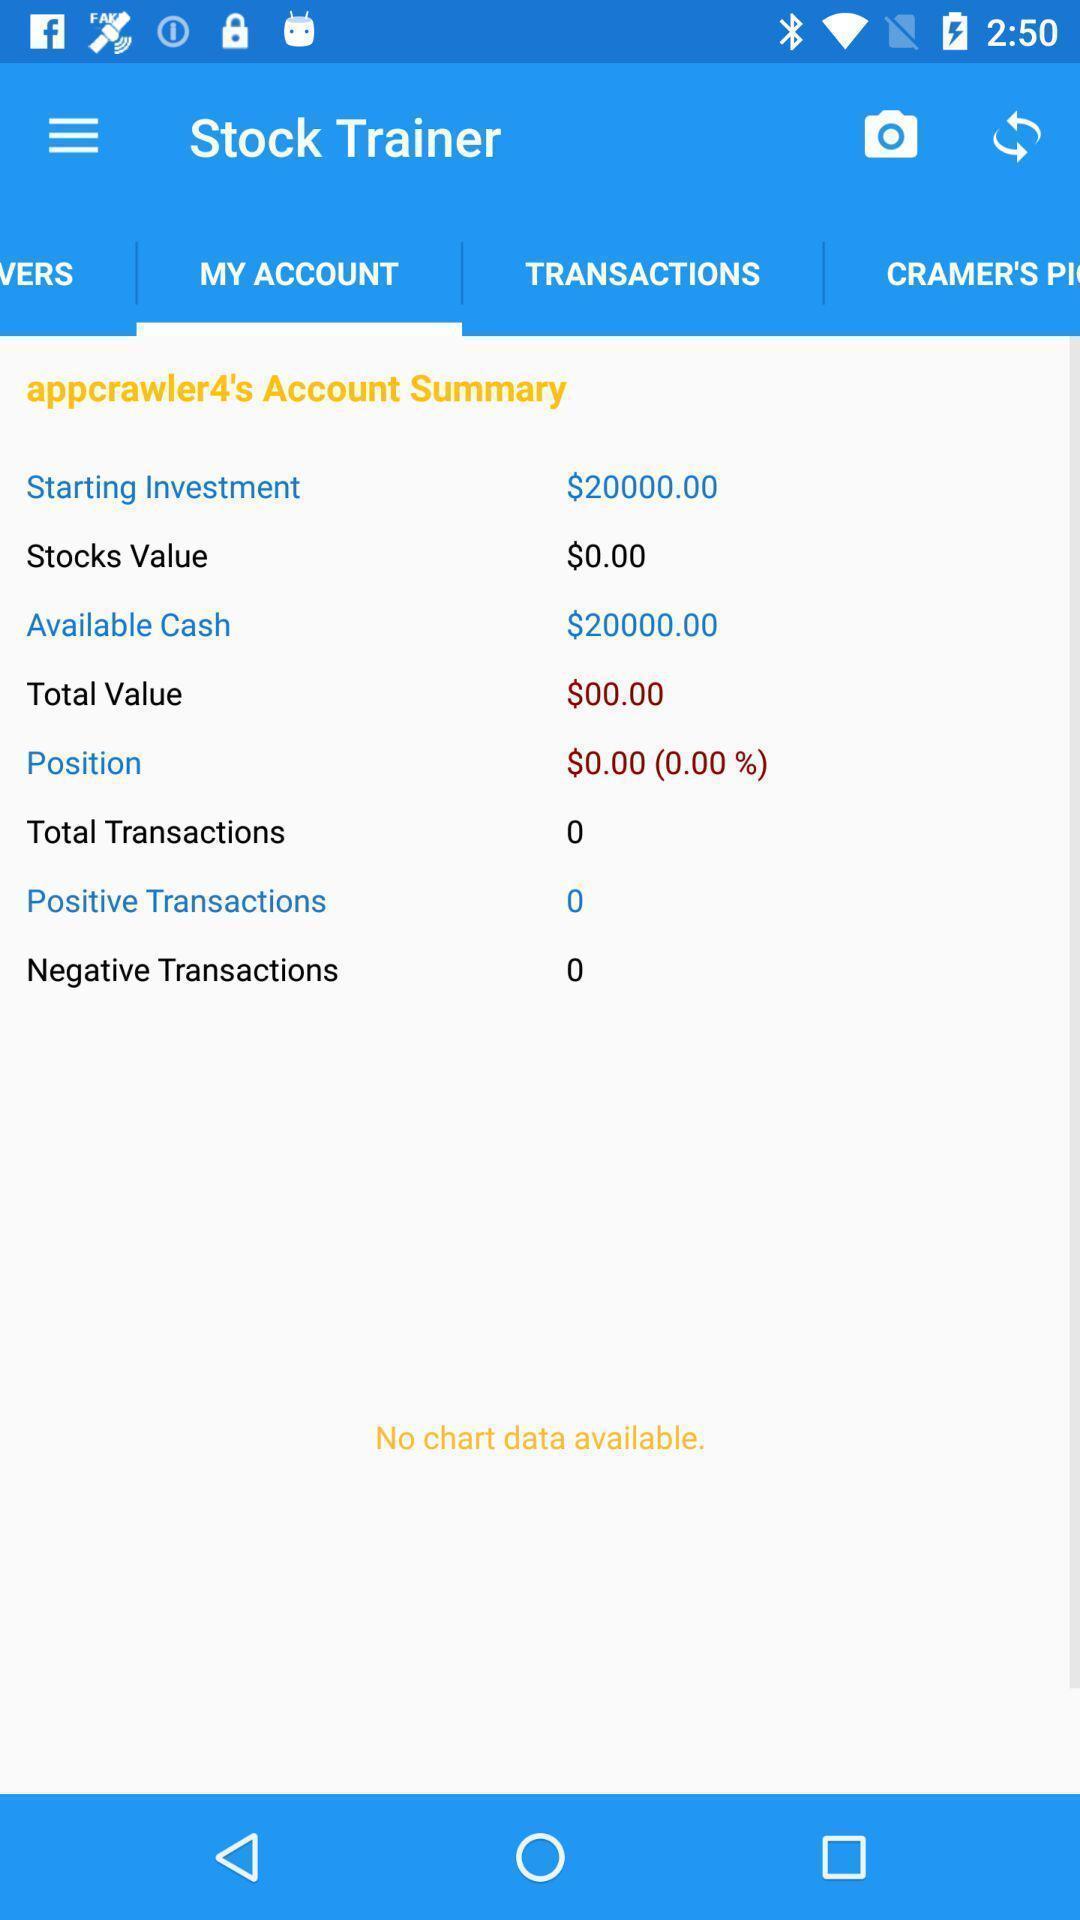Summarize the information in this screenshot. Screen shows stock details of an account. 